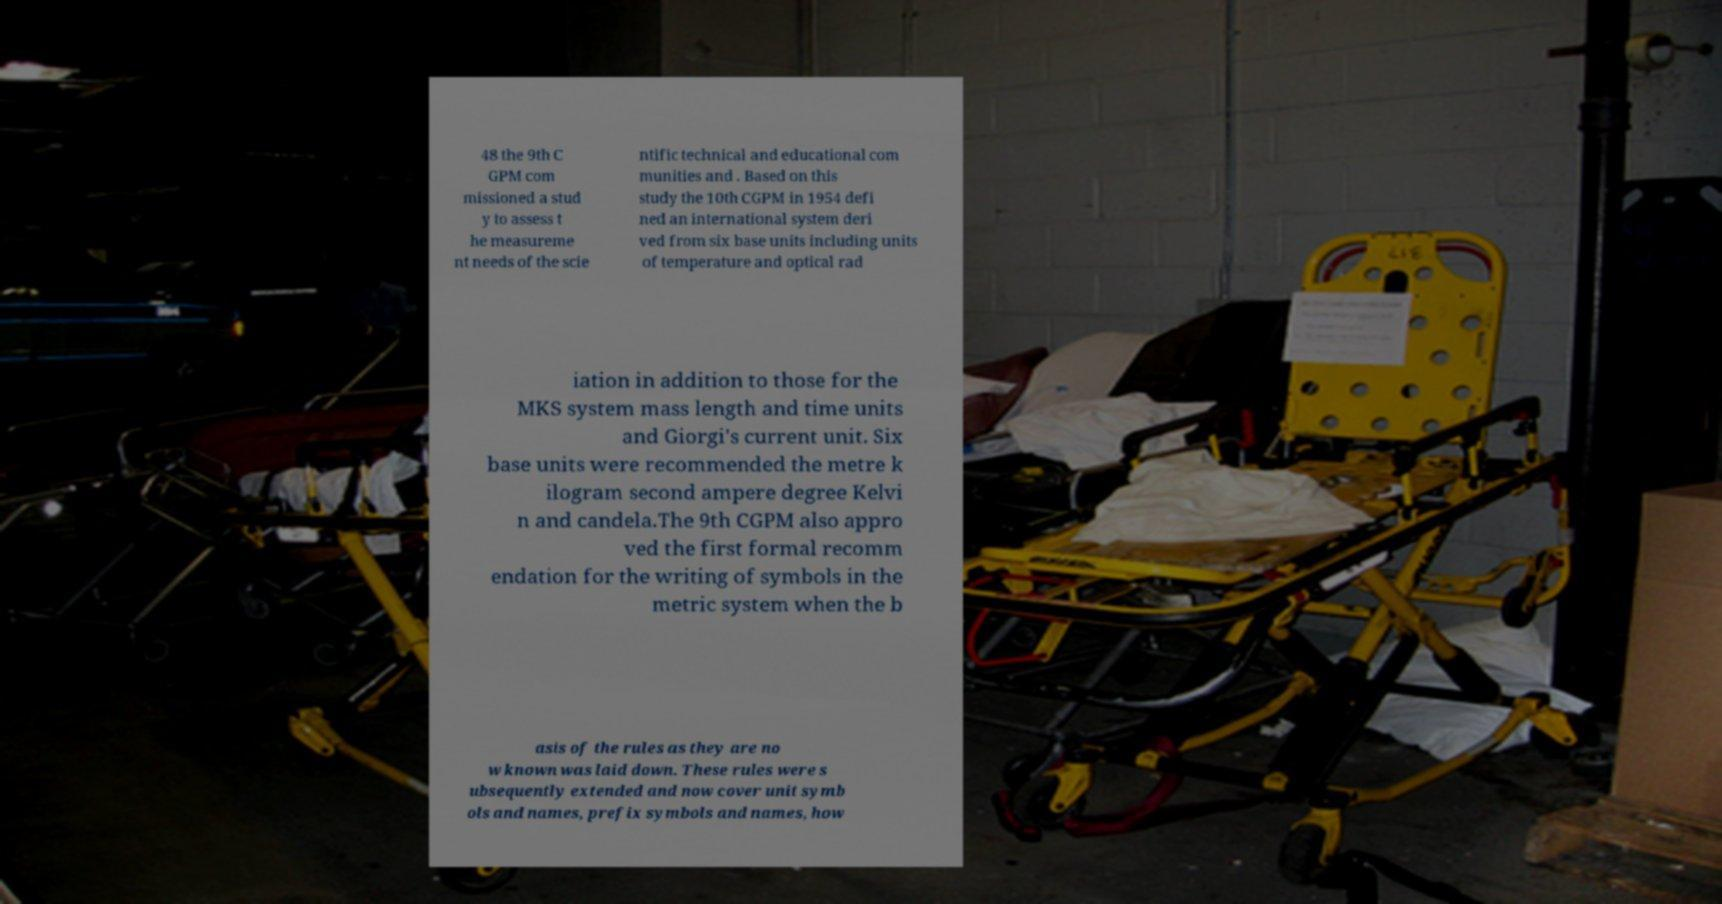Can you accurately transcribe the text from the provided image for me? 48 the 9th C GPM com missioned a stud y to assess t he measureme nt needs of the scie ntific technical and educational com munities and . Based on this study the 10th CGPM in 1954 defi ned an international system deri ved from six base units including units of temperature and optical rad iation in addition to those for the MKS system mass length and time units and Giorgi's current unit. Six base units were recommended the metre k ilogram second ampere degree Kelvi n and candela.The 9th CGPM also appro ved the first formal recomm endation for the writing of symbols in the metric system when the b asis of the rules as they are no w known was laid down. These rules were s ubsequently extended and now cover unit symb ols and names, prefix symbols and names, how 